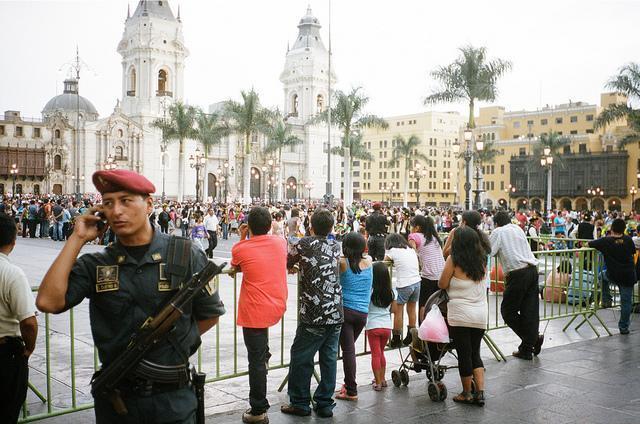How many people can be seen?
Give a very brief answer. 8. How many black cars are under a cat?
Give a very brief answer. 0. 